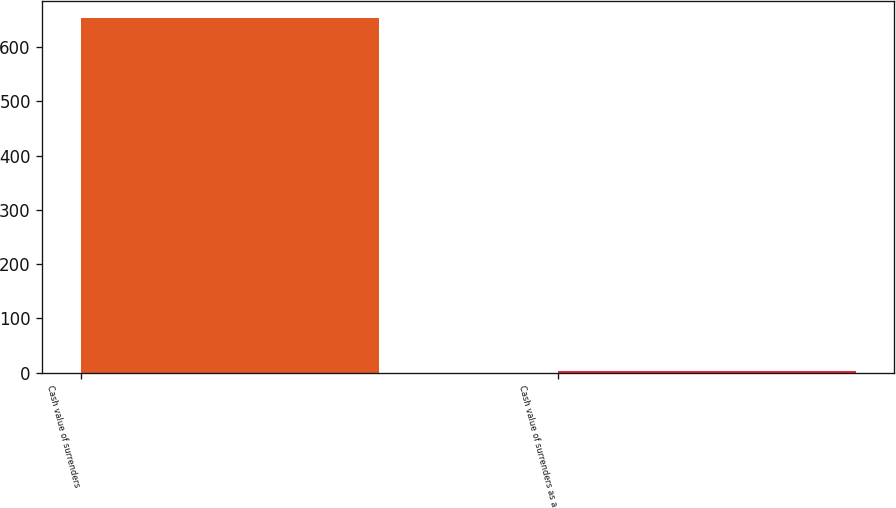Convert chart to OTSL. <chart><loc_0><loc_0><loc_500><loc_500><bar_chart><fcel>Cash value of surrenders<fcel>Cash value of surrenders as a<nl><fcel>653<fcel>3.8<nl></chart> 